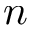<formula> <loc_0><loc_0><loc_500><loc_500>n</formula> 